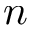<formula> <loc_0><loc_0><loc_500><loc_500>n</formula> 